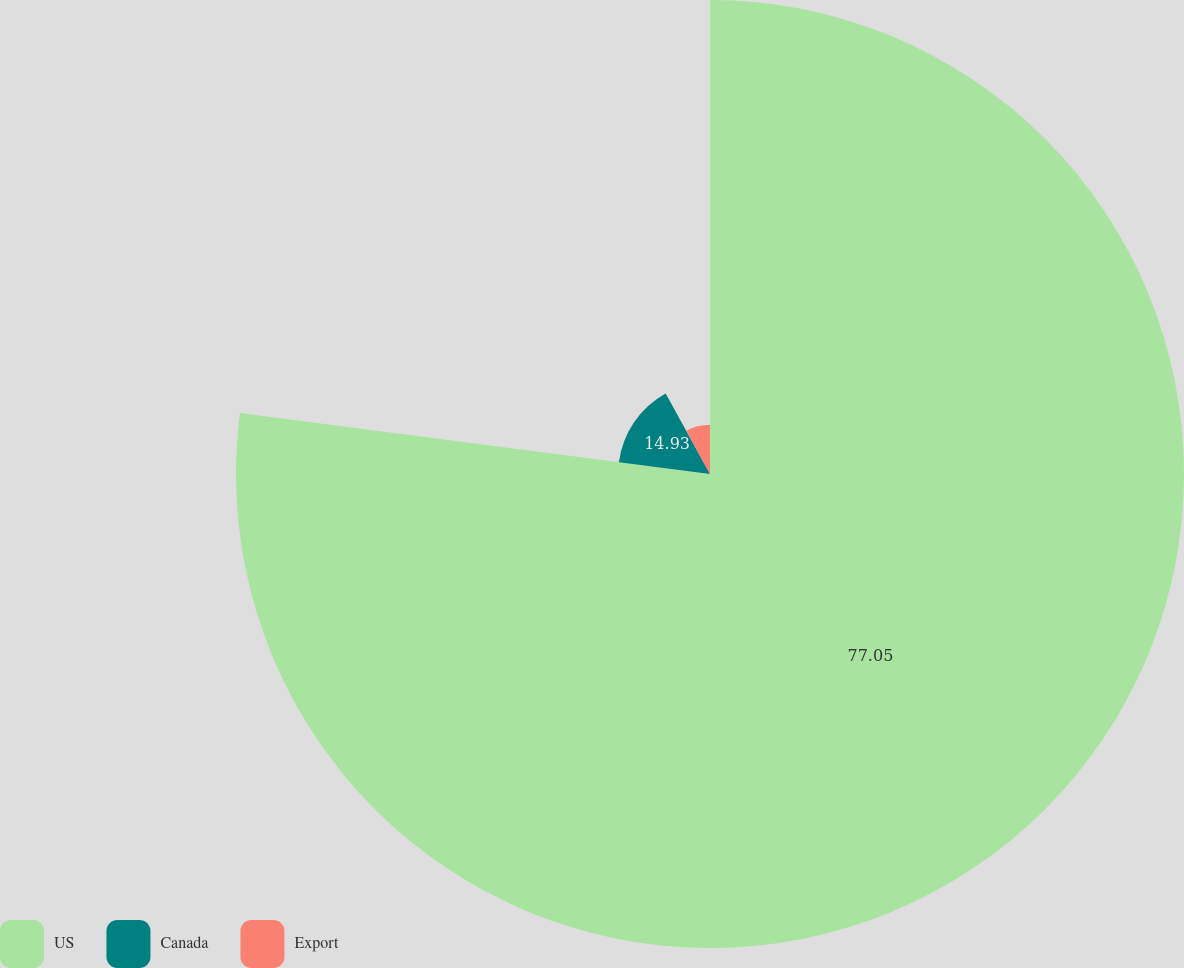Convert chart. <chart><loc_0><loc_0><loc_500><loc_500><pie_chart><fcel>US<fcel>Canada<fcel>Export<nl><fcel>77.05%<fcel>14.93%<fcel>8.02%<nl></chart> 